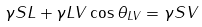<formula> <loc_0><loc_0><loc_500><loc_500>\gamma S L + \gamma L V \cos \theta _ { L V } = \gamma S V</formula> 